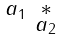<formula> <loc_0><loc_0><loc_500><loc_500>\begin{smallmatrix} a _ { 1 } & \ast \\ & a _ { 2 } \end{smallmatrix}</formula> 